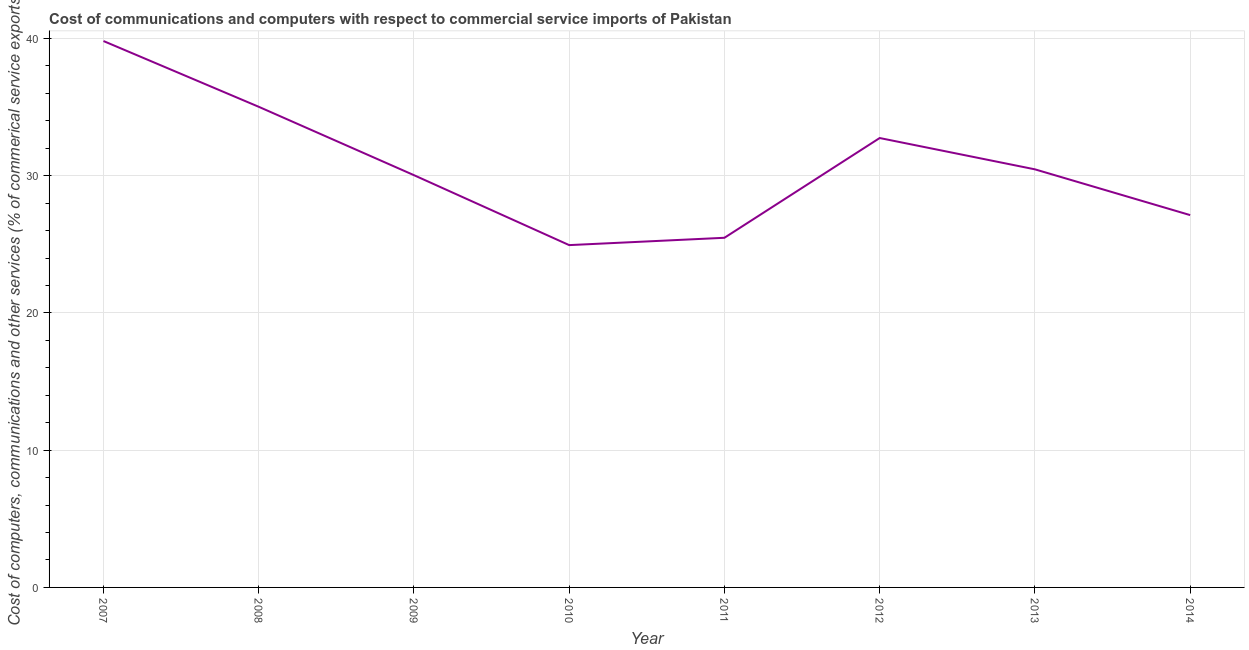What is the  computer and other services in 2011?
Offer a terse response. 25.48. Across all years, what is the maximum cost of communications?
Give a very brief answer. 39.82. Across all years, what is the minimum cost of communications?
Offer a terse response. 24.95. In which year was the  computer and other services minimum?
Offer a very short reply. 2010. What is the sum of the cost of communications?
Your answer should be compact. 245.67. What is the difference between the cost of communications in 2007 and 2011?
Give a very brief answer. 14.34. What is the average  computer and other services per year?
Give a very brief answer. 30.71. What is the median cost of communications?
Ensure brevity in your answer.  30.26. In how many years, is the  computer and other services greater than 38 %?
Keep it short and to the point. 1. What is the ratio of the  computer and other services in 2007 to that in 2014?
Provide a succinct answer. 1.47. What is the difference between the highest and the second highest  computer and other services?
Ensure brevity in your answer.  4.79. Is the sum of the  computer and other services in 2010 and 2013 greater than the maximum  computer and other services across all years?
Your response must be concise. Yes. What is the difference between the highest and the lowest  computer and other services?
Your answer should be very brief. 14.87. Does the cost of communications monotonically increase over the years?
Make the answer very short. No. How many lines are there?
Make the answer very short. 1. How many years are there in the graph?
Give a very brief answer. 8. What is the difference between two consecutive major ticks on the Y-axis?
Provide a short and direct response. 10. Does the graph contain any zero values?
Give a very brief answer. No. Does the graph contain grids?
Provide a succinct answer. Yes. What is the title of the graph?
Ensure brevity in your answer.  Cost of communications and computers with respect to commercial service imports of Pakistan. What is the label or title of the X-axis?
Keep it short and to the point. Year. What is the label or title of the Y-axis?
Provide a short and direct response. Cost of computers, communications and other services (% of commerical service exports). What is the Cost of computers, communications and other services (% of commerical service exports) in 2007?
Keep it short and to the point. 39.82. What is the Cost of computers, communications and other services (% of commerical service exports) in 2008?
Your answer should be very brief. 35.03. What is the Cost of computers, communications and other services (% of commerical service exports) in 2009?
Offer a very short reply. 30.04. What is the Cost of computers, communications and other services (% of commerical service exports) in 2010?
Give a very brief answer. 24.95. What is the Cost of computers, communications and other services (% of commerical service exports) of 2011?
Offer a very short reply. 25.48. What is the Cost of computers, communications and other services (% of commerical service exports) of 2012?
Keep it short and to the point. 32.75. What is the Cost of computers, communications and other services (% of commerical service exports) in 2013?
Your answer should be very brief. 30.47. What is the Cost of computers, communications and other services (% of commerical service exports) in 2014?
Make the answer very short. 27.13. What is the difference between the Cost of computers, communications and other services (% of commerical service exports) in 2007 and 2008?
Your answer should be compact. 4.79. What is the difference between the Cost of computers, communications and other services (% of commerical service exports) in 2007 and 2009?
Your answer should be compact. 9.78. What is the difference between the Cost of computers, communications and other services (% of commerical service exports) in 2007 and 2010?
Your answer should be very brief. 14.87. What is the difference between the Cost of computers, communications and other services (% of commerical service exports) in 2007 and 2011?
Ensure brevity in your answer.  14.34. What is the difference between the Cost of computers, communications and other services (% of commerical service exports) in 2007 and 2012?
Offer a very short reply. 7.07. What is the difference between the Cost of computers, communications and other services (% of commerical service exports) in 2007 and 2013?
Provide a short and direct response. 9.35. What is the difference between the Cost of computers, communications and other services (% of commerical service exports) in 2007 and 2014?
Offer a very short reply. 12.69. What is the difference between the Cost of computers, communications and other services (% of commerical service exports) in 2008 and 2009?
Offer a terse response. 4.98. What is the difference between the Cost of computers, communications and other services (% of commerical service exports) in 2008 and 2010?
Your answer should be compact. 10.08. What is the difference between the Cost of computers, communications and other services (% of commerical service exports) in 2008 and 2011?
Your response must be concise. 9.55. What is the difference between the Cost of computers, communications and other services (% of commerical service exports) in 2008 and 2012?
Keep it short and to the point. 2.28. What is the difference between the Cost of computers, communications and other services (% of commerical service exports) in 2008 and 2013?
Offer a very short reply. 4.56. What is the difference between the Cost of computers, communications and other services (% of commerical service exports) in 2008 and 2014?
Offer a terse response. 7.89. What is the difference between the Cost of computers, communications and other services (% of commerical service exports) in 2009 and 2010?
Give a very brief answer. 5.1. What is the difference between the Cost of computers, communications and other services (% of commerical service exports) in 2009 and 2011?
Your answer should be very brief. 4.56. What is the difference between the Cost of computers, communications and other services (% of commerical service exports) in 2009 and 2012?
Your response must be concise. -2.71. What is the difference between the Cost of computers, communications and other services (% of commerical service exports) in 2009 and 2013?
Offer a terse response. -0.42. What is the difference between the Cost of computers, communications and other services (% of commerical service exports) in 2009 and 2014?
Provide a succinct answer. 2.91. What is the difference between the Cost of computers, communications and other services (% of commerical service exports) in 2010 and 2011?
Provide a succinct answer. -0.53. What is the difference between the Cost of computers, communications and other services (% of commerical service exports) in 2010 and 2012?
Your response must be concise. -7.8. What is the difference between the Cost of computers, communications and other services (% of commerical service exports) in 2010 and 2013?
Offer a terse response. -5.52. What is the difference between the Cost of computers, communications and other services (% of commerical service exports) in 2010 and 2014?
Your answer should be very brief. -2.19. What is the difference between the Cost of computers, communications and other services (% of commerical service exports) in 2011 and 2012?
Provide a succinct answer. -7.27. What is the difference between the Cost of computers, communications and other services (% of commerical service exports) in 2011 and 2013?
Your answer should be very brief. -4.99. What is the difference between the Cost of computers, communications and other services (% of commerical service exports) in 2011 and 2014?
Offer a very short reply. -1.65. What is the difference between the Cost of computers, communications and other services (% of commerical service exports) in 2012 and 2013?
Give a very brief answer. 2.28. What is the difference between the Cost of computers, communications and other services (% of commerical service exports) in 2012 and 2014?
Offer a very short reply. 5.62. What is the difference between the Cost of computers, communications and other services (% of commerical service exports) in 2013 and 2014?
Keep it short and to the point. 3.34. What is the ratio of the Cost of computers, communications and other services (% of commerical service exports) in 2007 to that in 2008?
Make the answer very short. 1.14. What is the ratio of the Cost of computers, communications and other services (% of commerical service exports) in 2007 to that in 2009?
Your answer should be compact. 1.32. What is the ratio of the Cost of computers, communications and other services (% of commerical service exports) in 2007 to that in 2010?
Provide a short and direct response. 1.6. What is the ratio of the Cost of computers, communications and other services (% of commerical service exports) in 2007 to that in 2011?
Your answer should be compact. 1.56. What is the ratio of the Cost of computers, communications and other services (% of commerical service exports) in 2007 to that in 2012?
Keep it short and to the point. 1.22. What is the ratio of the Cost of computers, communications and other services (% of commerical service exports) in 2007 to that in 2013?
Provide a short and direct response. 1.31. What is the ratio of the Cost of computers, communications and other services (% of commerical service exports) in 2007 to that in 2014?
Make the answer very short. 1.47. What is the ratio of the Cost of computers, communications and other services (% of commerical service exports) in 2008 to that in 2009?
Keep it short and to the point. 1.17. What is the ratio of the Cost of computers, communications and other services (% of commerical service exports) in 2008 to that in 2010?
Give a very brief answer. 1.4. What is the ratio of the Cost of computers, communications and other services (% of commerical service exports) in 2008 to that in 2011?
Give a very brief answer. 1.38. What is the ratio of the Cost of computers, communications and other services (% of commerical service exports) in 2008 to that in 2012?
Your answer should be compact. 1.07. What is the ratio of the Cost of computers, communications and other services (% of commerical service exports) in 2008 to that in 2013?
Offer a terse response. 1.15. What is the ratio of the Cost of computers, communications and other services (% of commerical service exports) in 2008 to that in 2014?
Your answer should be very brief. 1.29. What is the ratio of the Cost of computers, communications and other services (% of commerical service exports) in 2009 to that in 2010?
Make the answer very short. 1.2. What is the ratio of the Cost of computers, communications and other services (% of commerical service exports) in 2009 to that in 2011?
Provide a short and direct response. 1.18. What is the ratio of the Cost of computers, communications and other services (% of commerical service exports) in 2009 to that in 2012?
Provide a short and direct response. 0.92. What is the ratio of the Cost of computers, communications and other services (% of commerical service exports) in 2009 to that in 2013?
Give a very brief answer. 0.99. What is the ratio of the Cost of computers, communications and other services (% of commerical service exports) in 2009 to that in 2014?
Give a very brief answer. 1.11. What is the ratio of the Cost of computers, communications and other services (% of commerical service exports) in 2010 to that in 2012?
Provide a succinct answer. 0.76. What is the ratio of the Cost of computers, communications and other services (% of commerical service exports) in 2010 to that in 2013?
Provide a succinct answer. 0.82. What is the ratio of the Cost of computers, communications and other services (% of commerical service exports) in 2010 to that in 2014?
Offer a very short reply. 0.92. What is the ratio of the Cost of computers, communications and other services (% of commerical service exports) in 2011 to that in 2012?
Make the answer very short. 0.78. What is the ratio of the Cost of computers, communications and other services (% of commerical service exports) in 2011 to that in 2013?
Give a very brief answer. 0.84. What is the ratio of the Cost of computers, communications and other services (% of commerical service exports) in 2011 to that in 2014?
Make the answer very short. 0.94. What is the ratio of the Cost of computers, communications and other services (% of commerical service exports) in 2012 to that in 2013?
Offer a very short reply. 1.07. What is the ratio of the Cost of computers, communications and other services (% of commerical service exports) in 2012 to that in 2014?
Keep it short and to the point. 1.21. What is the ratio of the Cost of computers, communications and other services (% of commerical service exports) in 2013 to that in 2014?
Make the answer very short. 1.12. 